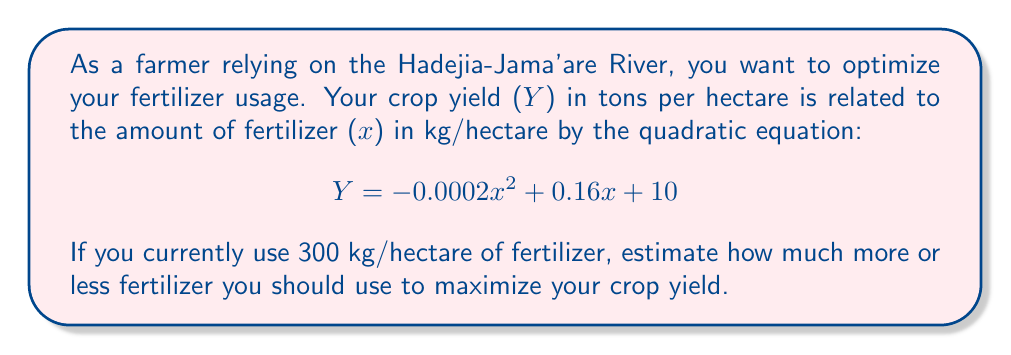Can you answer this question? To find the optimal amount of fertilizer, we need to find the vertex of the parabola described by the quadratic equation. The vertex represents the maximum point of the parabola.

1. The quadratic equation is in the form $Y = ax^2 + bx + c$, where:
   $a = -0.0002$
   $b = 0.16$
   $c = 10$

2. For a quadratic equation, the x-coordinate of the vertex is given by $x = -\frac{b}{2a}$

3. Calculate the optimal amount of fertilizer:
   $$x = -\frac{0.16}{2(-0.0002)} = -\frac{0.16}{-0.0004} = 400$$

4. The optimal amount of fertilizer is 400 kg/hectare.

5. Calculate the difference from current usage:
   $400 - 300 = 100$

Therefore, you should use 100 kg/hectare more fertilizer to maximize your crop yield.
Answer: 100 kg/hectare more 